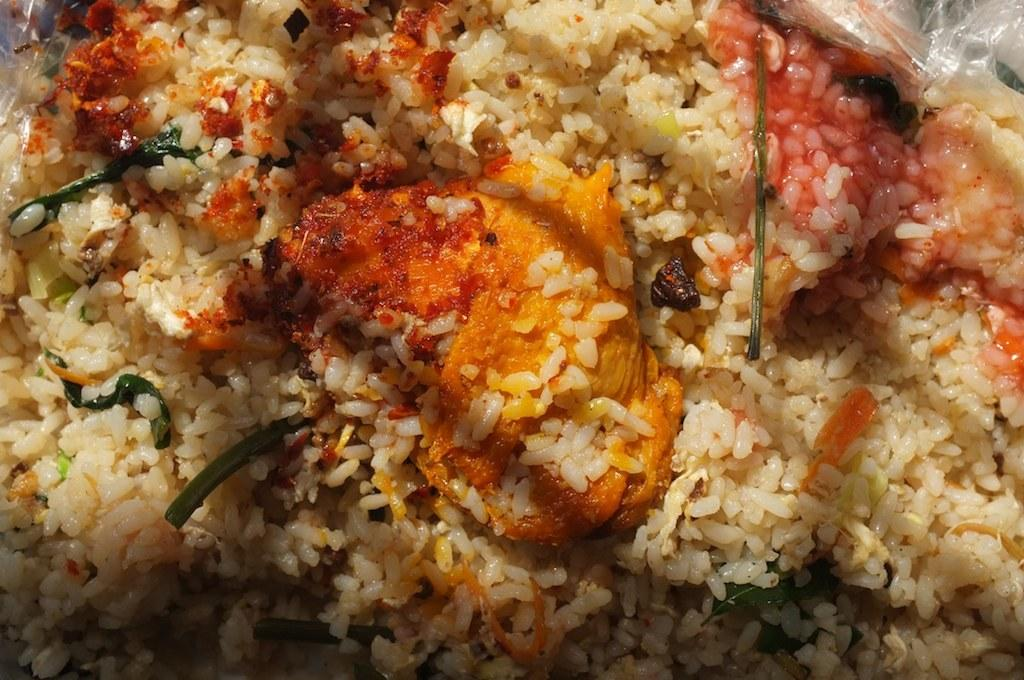What type of food is visible in the image? There is rice in the image. What accompanies the rice in the image? There is curry mixed with the rice in the image. What type of bird can be seen eating a pie in the image? There is no bird or pie present in the image; it only features rice and curry. 